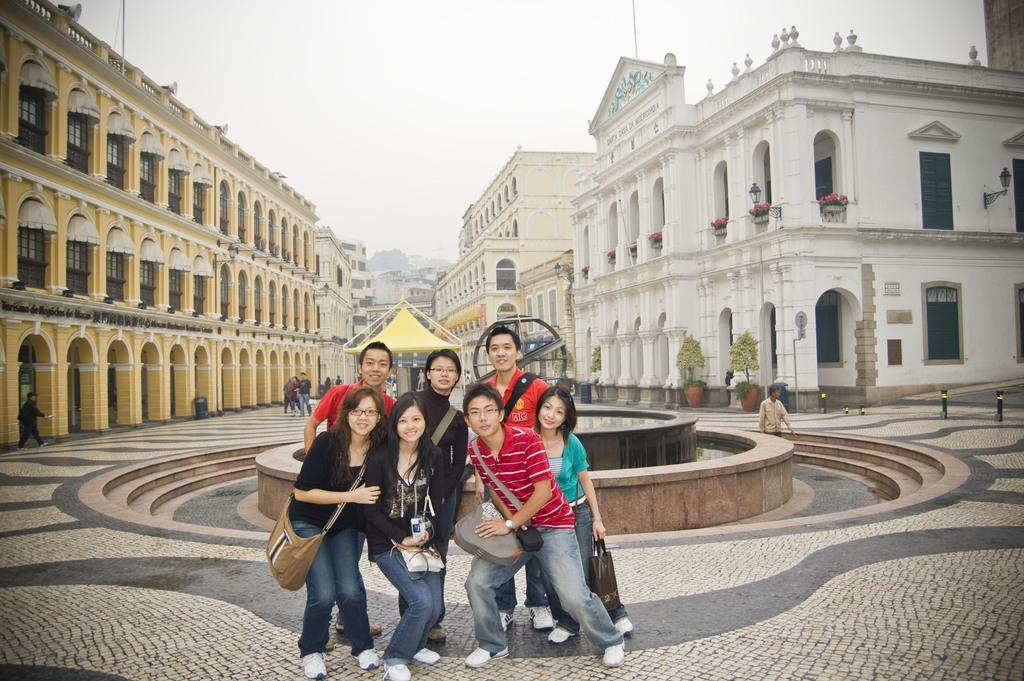What is the main subject of the image? The main subject of the image is a group of persons standing in the center. Where are the persons standing? The group of persons is standing on the floor. What can be seen in the background of the image? In the background of the image, there is a fountain, persons, buildings, trees, and the sky. What season is it during the summer recess in the image? There is no mention of summer or recess in the image, so it is not possible to determine the season or whether there is a recess. 